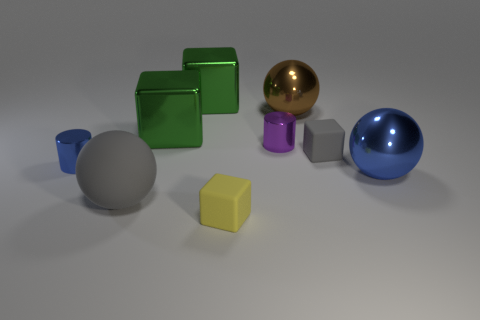Are there more tiny yellow blocks that are left of the small yellow thing than large gray matte balls?
Make the answer very short. No. What number of blocks are the same size as the yellow thing?
Provide a succinct answer. 1. There is a cube that is in front of the large blue sphere; is it the same size as the gray matte cube that is right of the tiny blue shiny cylinder?
Your answer should be compact. Yes. How big is the gray matte thing right of the tiny yellow thing?
Give a very brief answer. Small. What size is the gray matte thing that is left of the tiny matte cube that is left of the large brown ball?
Ensure brevity in your answer.  Large. What material is the blue cylinder that is the same size as the purple shiny object?
Offer a very short reply. Metal. There is a gray rubber cube; are there any small blue shiny objects right of it?
Offer a very short reply. No. Is the number of blue objects that are behind the purple cylinder the same as the number of green matte things?
Your answer should be compact. Yes. What is the shape of the rubber thing that is the same size as the gray cube?
Provide a succinct answer. Cube. What is the tiny yellow thing made of?
Your answer should be compact. Rubber. 